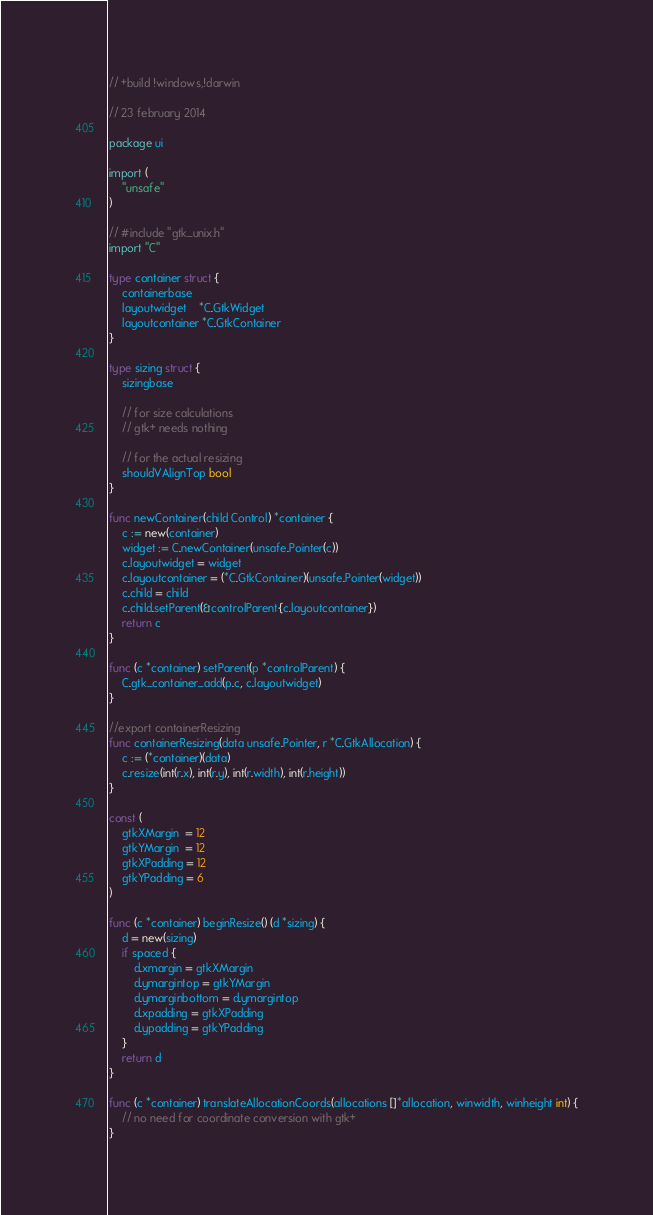<code> <loc_0><loc_0><loc_500><loc_500><_Go_>// +build !windows,!darwin

// 23 february 2014

package ui

import (
	"unsafe"
)

// #include "gtk_unix.h"
import "C"

type container struct {
	containerbase
	layoutwidget    *C.GtkWidget
	layoutcontainer *C.GtkContainer
}

type sizing struct {
	sizingbase

	// for size calculations
	// gtk+ needs nothing

	// for the actual resizing
	shouldVAlignTop bool
}

func newContainer(child Control) *container {
	c := new(container)
	widget := C.newContainer(unsafe.Pointer(c))
	c.layoutwidget = widget
	c.layoutcontainer = (*C.GtkContainer)(unsafe.Pointer(widget))
	c.child = child
	c.child.setParent(&controlParent{c.layoutcontainer})
	return c
}

func (c *container) setParent(p *controlParent) {
	C.gtk_container_add(p.c, c.layoutwidget)
}

//export containerResizing
func containerResizing(data unsafe.Pointer, r *C.GtkAllocation) {
	c := (*container)(data)
	c.resize(int(r.x), int(r.y), int(r.width), int(r.height))
}

const (
	gtkXMargin  = 12
	gtkYMargin  = 12
	gtkXPadding = 12
	gtkYPadding = 6
)

func (c *container) beginResize() (d *sizing) {
	d = new(sizing)
	if spaced {
		d.xmargin = gtkXMargin
		d.ymargintop = gtkYMargin
		d.ymarginbottom = d.ymargintop
		d.xpadding = gtkXPadding
		d.ypadding = gtkYPadding
	}
	return d
}

func (c *container) translateAllocationCoords(allocations []*allocation, winwidth, winheight int) {
	// no need for coordinate conversion with gtk+
}
</code> 